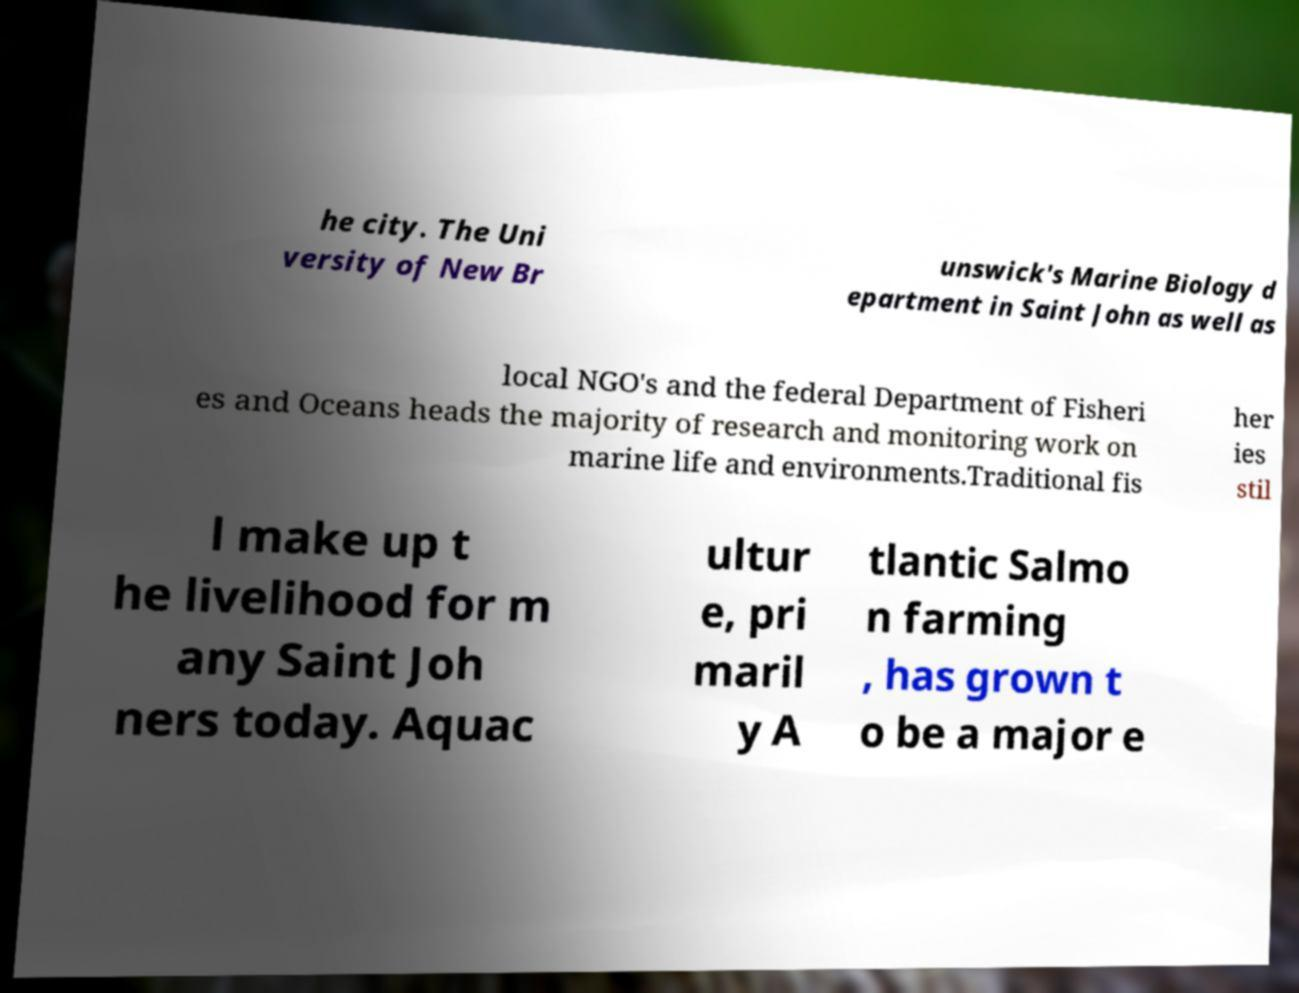Please identify and transcribe the text found in this image. he city. The Uni versity of New Br unswick's Marine Biology d epartment in Saint John as well as local NGO's and the federal Department of Fisheri es and Oceans heads the majority of research and monitoring work on marine life and environments.Traditional fis her ies stil l make up t he livelihood for m any Saint Joh ners today. Aquac ultur e, pri maril y A tlantic Salmo n farming , has grown t o be a major e 